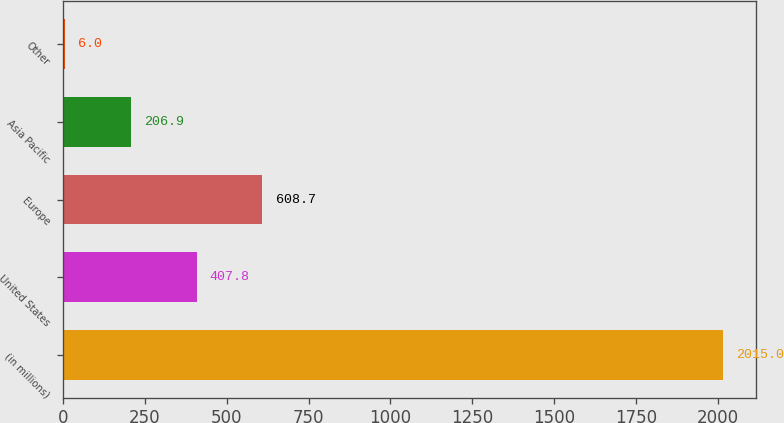Convert chart. <chart><loc_0><loc_0><loc_500><loc_500><bar_chart><fcel>(in millions)<fcel>United States<fcel>Europe<fcel>Asia Pacific<fcel>Other<nl><fcel>2015<fcel>407.8<fcel>608.7<fcel>206.9<fcel>6<nl></chart> 